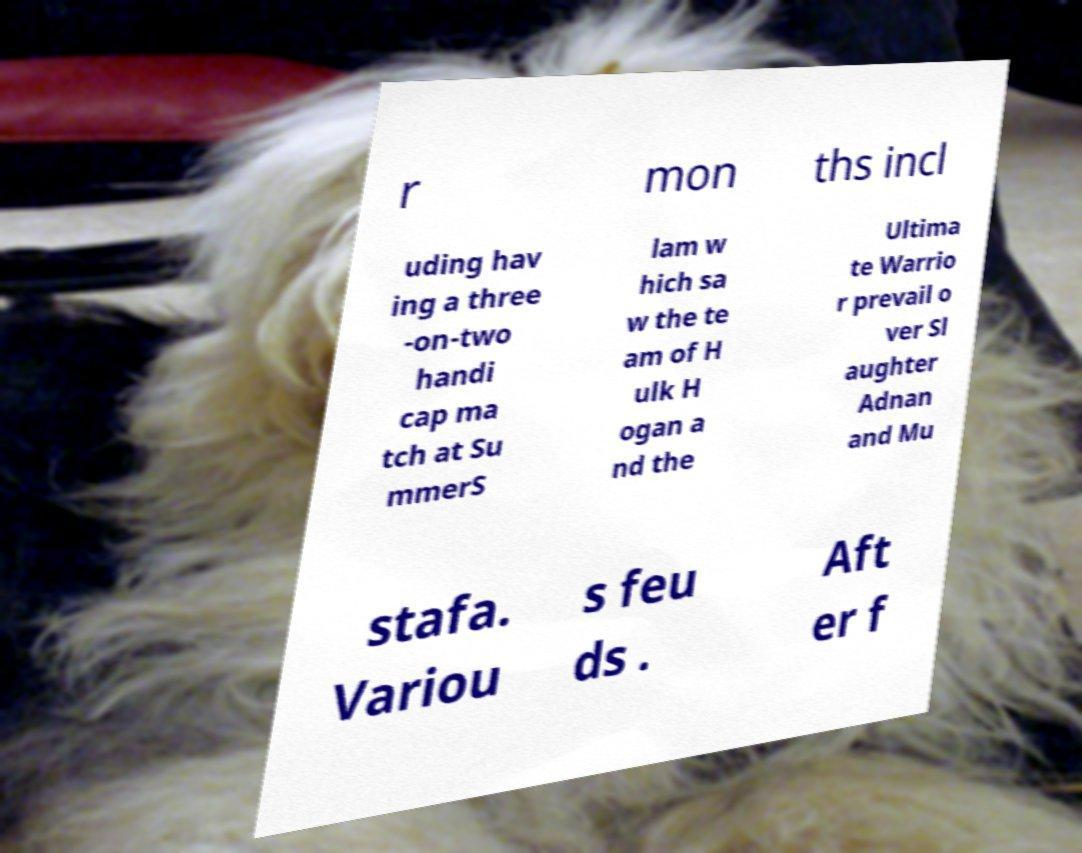What messages or text are displayed in this image? I need them in a readable, typed format. r mon ths incl uding hav ing a three -on-two handi cap ma tch at Su mmerS lam w hich sa w the te am of H ulk H ogan a nd the Ultima te Warrio r prevail o ver Sl aughter Adnan and Mu stafa. Variou s feu ds . Aft er f 